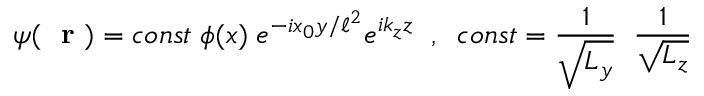Convert formula to latex. <formula><loc_0><loc_0><loc_500><loc_500>\psi ( r ) = c o n s t \, \phi ( x ) \, e ^ { - i x _ { 0 } y / \ell ^ { 2 } } e ^ { i k _ { z } z } \, , \, c o n s t = \frac { 1 } { \sqrt { L _ { y } } } \, \frac { 1 } { \sqrt { L _ { z } } }</formula> 